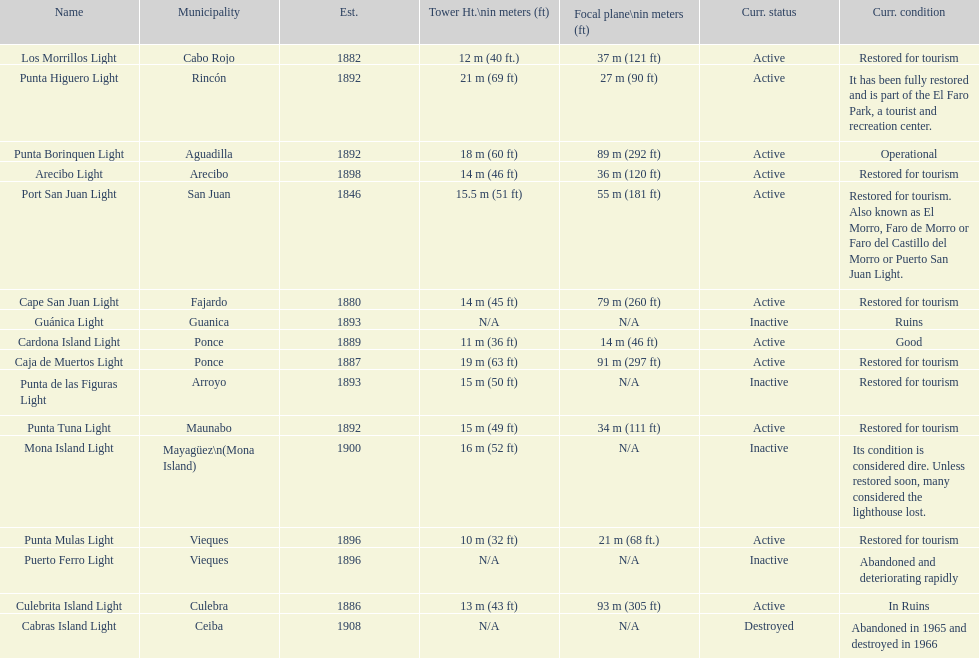How many towers are at least 18 meters tall? 3. 